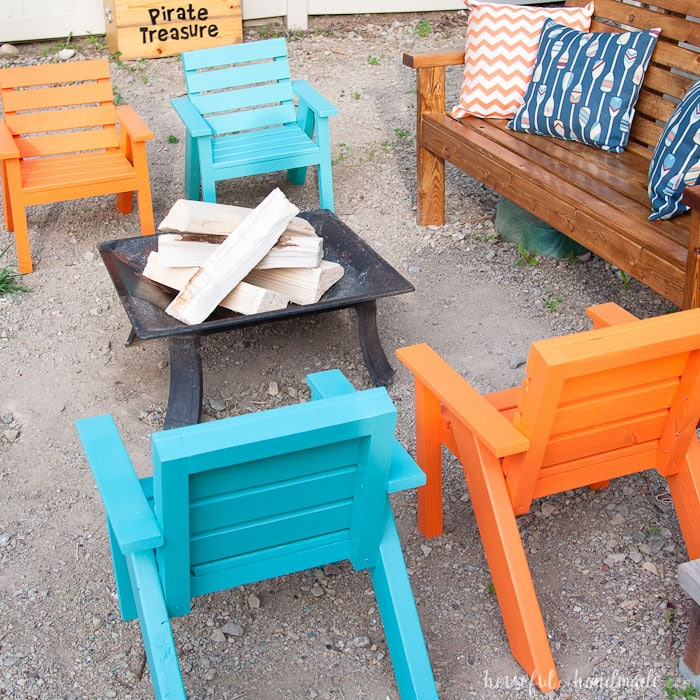How could a host incorporate a culinary experience into this setting? A host could enhance the culinary experience by setting up a small outdoor table with a variety of snacks and beverages, themed around the 'Pirate Treasure' motif. They could serve tropical drinks adorned with little paper umbrellas or offer a selection of seafood dishes, perhaps grilled over the fire pit. For dessert, guests could enjoy roasting marshmallows and creating s'mores, or even a themed 'pirate cake.' Incorporating interactive food stations, such as a DIY taco bar or a make-your-own sundae station, would also be a hit, allowing guests to customize their meals and enjoy a hands-on dining experience. 